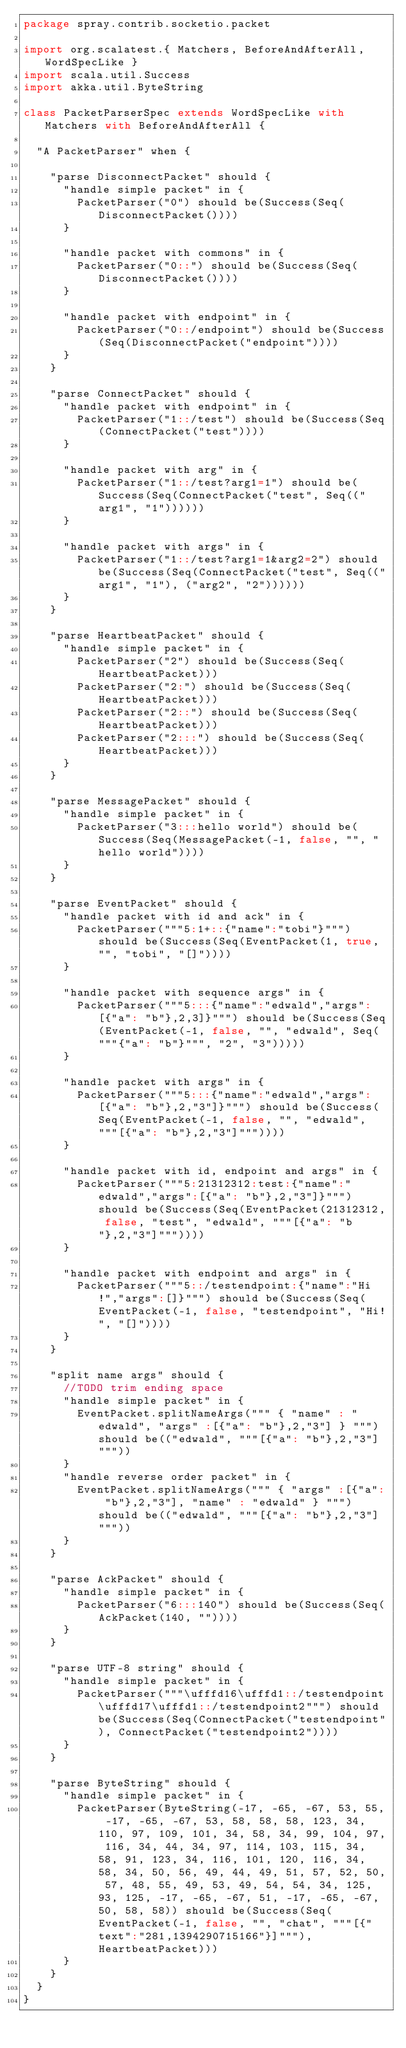<code> <loc_0><loc_0><loc_500><loc_500><_Scala_>package spray.contrib.socketio.packet

import org.scalatest.{ Matchers, BeforeAndAfterAll, WordSpecLike }
import scala.util.Success
import akka.util.ByteString

class PacketParserSpec extends WordSpecLike with Matchers with BeforeAndAfterAll {

  "A PacketParser" when {

    "parse DisconnectPacket" should {
      "handle simple packet" in {
        PacketParser("0") should be(Success(Seq(DisconnectPacket())))
      }

      "handle packet with commons" in {
        PacketParser("0::") should be(Success(Seq(DisconnectPacket())))
      }

      "handle packet with endpoint" in {
        PacketParser("0::/endpoint") should be(Success(Seq(DisconnectPacket("endpoint"))))
      }
    }

    "parse ConnectPacket" should {
      "handle packet with endpoint" in {
        PacketParser("1::/test") should be(Success(Seq(ConnectPacket("test"))))
      }

      "handle packet with arg" in {
        PacketParser("1::/test?arg1=1") should be(Success(Seq(ConnectPacket("test", Seq(("arg1", "1"))))))
      }

      "handle packet with args" in {
        PacketParser("1::/test?arg1=1&arg2=2") should be(Success(Seq(ConnectPacket("test", Seq(("arg1", "1"), ("arg2", "2"))))))
      }
    }

    "parse HeartbeatPacket" should {
      "handle simple packet" in {
        PacketParser("2") should be(Success(Seq(HeartbeatPacket)))
        PacketParser("2:") should be(Success(Seq(HeartbeatPacket)))
        PacketParser("2::") should be(Success(Seq(HeartbeatPacket)))
        PacketParser("2:::") should be(Success(Seq(HeartbeatPacket)))
      }
    }

    "parse MessagePacket" should {
      "handle simple packet" in {
        PacketParser("3:::hello world") should be(Success(Seq(MessagePacket(-1, false, "", "hello world"))))
      }
    }

    "parse EventPacket" should {
      "handle packet with id and ack" in {
        PacketParser("""5:1+::{"name":"tobi"}""") should be(Success(Seq(EventPacket(1, true, "", "tobi", "[]"))))
      }

      "handle packet with sequence args" in {
        PacketParser("""5:::{"name":"edwald","args":[{"a": "b"},2,3]}""") should be(Success(Seq(EventPacket(-1, false, "", "edwald", Seq("""{"a": "b"}""", "2", "3")))))
      }

      "handle packet with args" in {
        PacketParser("""5:::{"name":"edwald","args":[{"a": "b"},2,"3"]}""") should be(Success(Seq(EventPacket(-1, false, "", "edwald", """[{"a": "b"},2,"3"]"""))))
      }

      "handle packet with id, endpoint and args" in {
        PacketParser("""5:21312312:test:{"name":"edwald","args":[{"a": "b"},2,"3"]}""") should be(Success(Seq(EventPacket(21312312, false, "test", "edwald", """[{"a": "b"},2,"3"]"""))))
      }

      "handle packet with endpoint and args" in {
        PacketParser("""5::/testendpoint:{"name":"Hi!","args":[]}""") should be(Success(Seq(EventPacket(-1, false, "testendpoint", "Hi!", "[]"))))
      }
    }

    "split name args" should {
      //TODO trim ending space
      "handle simple packet" in {
        EventPacket.splitNameArgs(""" { "name" : "edwald", "args" :[{"a": "b"},2,"3"] } """) should be(("edwald", """[{"a": "b"},2,"3"] """))
      }
      "handle reverse order packet" in {
        EventPacket.splitNameArgs(""" { "args" :[{"a": "b"},2,"3"], "name" : "edwald" } """) should be(("edwald", """[{"a": "b"},2,"3"]"""))
      }
    }

    "parse AckPacket" should {
      "handle simple packet" in {
        PacketParser("6:::140") should be(Success(Seq(AckPacket(140, ""))))
      }
    }

    "parse UTF-8 string" should {
      "handle simple packet" in {
        PacketParser("""\ufffd16\ufffd1::/testendpoint\ufffd17\ufffd1::/testendpoint2""") should be(Success(Seq(ConnectPacket("testendpoint"), ConnectPacket("testendpoint2"))))
      }
    }

    "parse ByteString" should {
      "handle simple packet" in {
        PacketParser(ByteString(-17, -65, -67, 53, 55, -17, -65, -67, 53, 58, 58, 58, 123, 34, 110, 97, 109, 101, 34, 58, 34, 99, 104, 97, 116, 34, 44, 34, 97, 114, 103, 115, 34, 58, 91, 123, 34, 116, 101, 120, 116, 34, 58, 34, 50, 56, 49, 44, 49, 51, 57, 52, 50, 57, 48, 55, 49, 53, 49, 54, 54, 34, 125, 93, 125, -17, -65, -67, 51, -17, -65, -67, 50, 58, 58)) should be(Success(Seq(EventPacket(-1, false, "", "chat", """[{"text":"281,1394290715166"}]"""), HeartbeatPacket)))
      }
    }
  }
}
</code> 